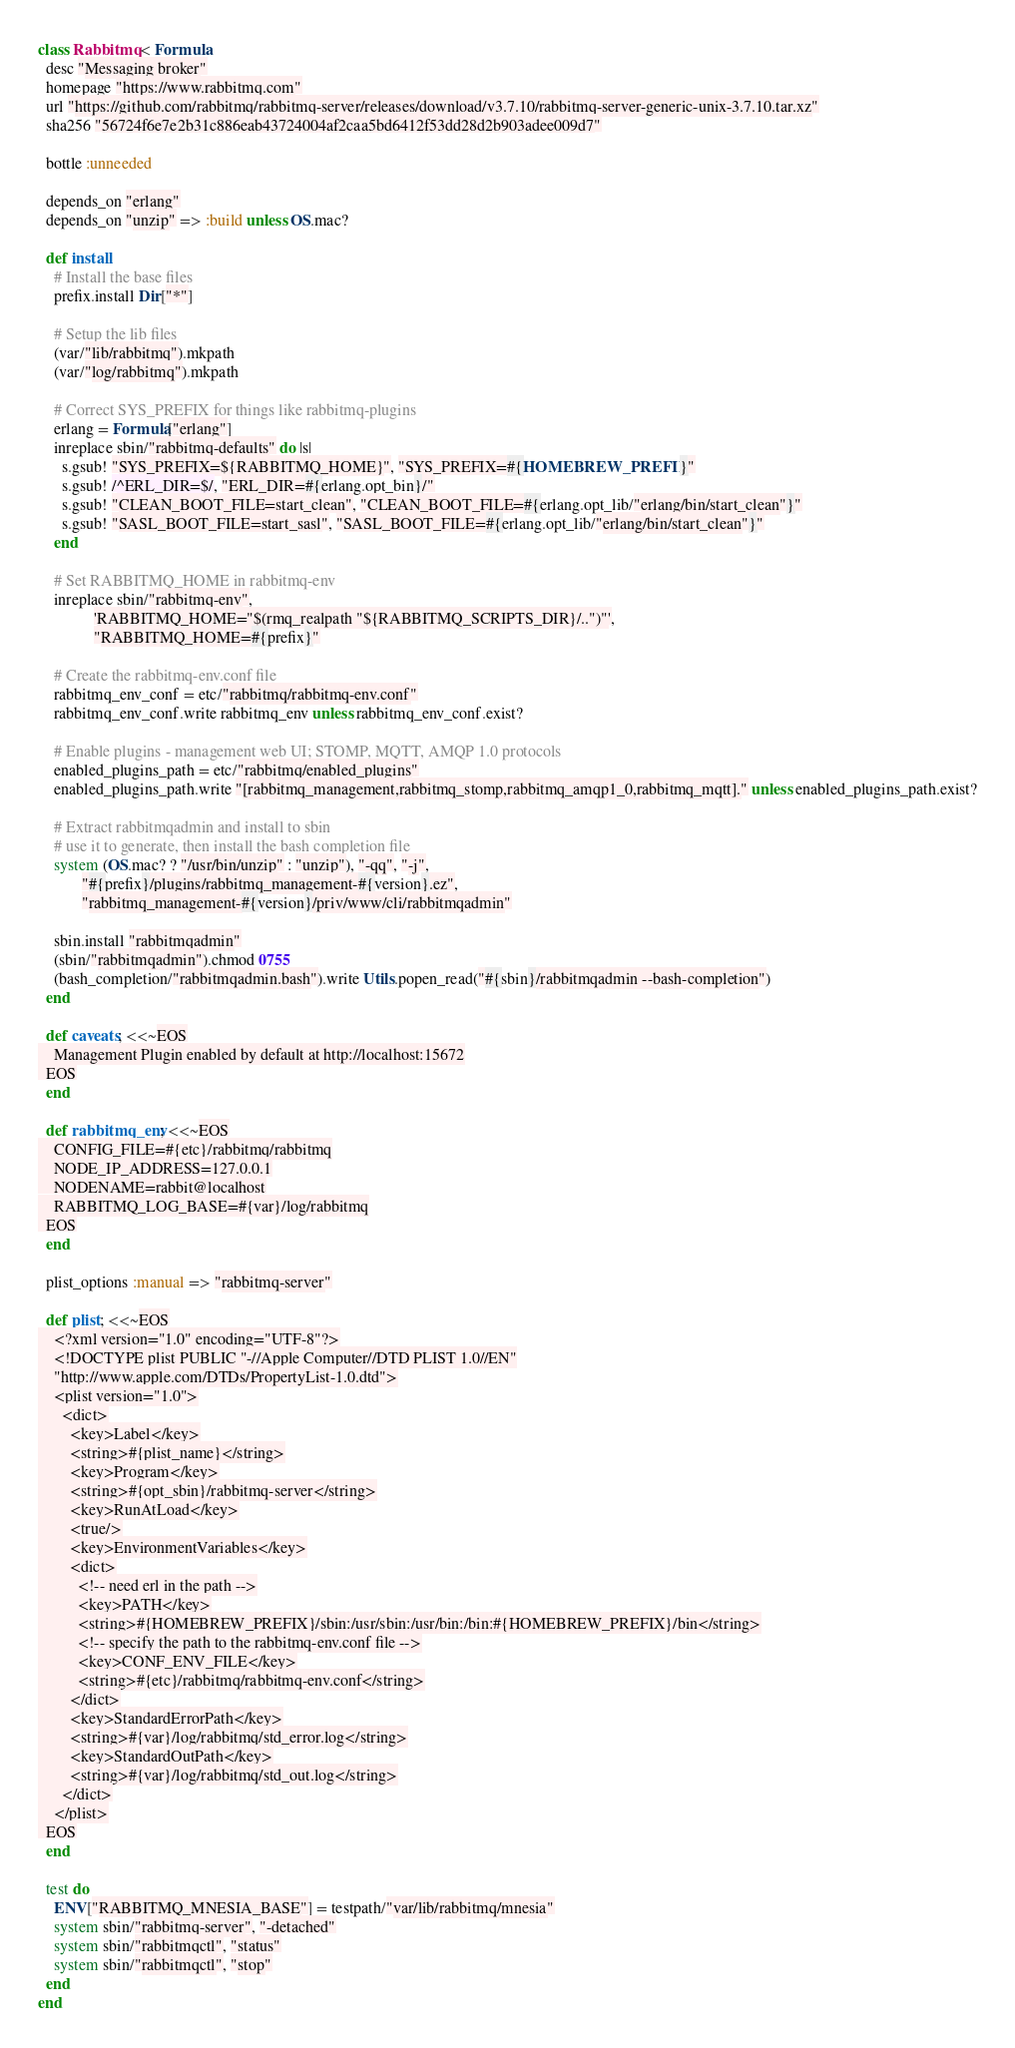Convert code to text. <code><loc_0><loc_0><loc_500><loc_500><_Ruby_>class Rabbitmq < Formula
  desc "Messaging broker"
  homepage "https://www.rabbitmq.com"
  url "https://github.com/rabbitmq/rabbitmq-server/releases/download/v3.7.10/rabbitmq-server-generic-unix-3.7.10.tar.xz"
  sha256 "56724f6e7e2b31c886eab43724004af2caa5bd6412f53dd28d2b903adee009d7"

  bottle :unneeded

  depends_on "erlang"
  depends_on "unzip" => :build unless OS.mac?

  def install
    # Install the base files
    prefix.install Dir["*"]

    # Setup the lib files
    (var/"lib/rabbitmq").mkpath
    (var/"log/rabbitmq").mkpath

    # Correct SYS_PREFIX for things like rabbitmq-plugins
    erlang = Formula["erlang"]
    inreplace sbin/"rabbitmq-defaults" do |s|
      s.gsub! "SYS_PREFIX=${RABBITMQ_HOME}", "SYS_PREFIX=#{HOMEBREW_PREFIX}"
      s.gsub! /^ERL_DIR=$/, "ERL_DIR=#{erlang.opt_bin}/"
      s.gsub! "CLEAN_BOOT_FILE=start_clean", "CLEAN_BOOT_FILE=#{erlang.opt_lib/"erlang/bin/start_clean"}"
      s.gsub! "SASL_BOOT_FILE=start_sasl", "SASL_BOOT_FILE=#{erlang.opt_lib/"erlang/bin/start_clean"}"
    end

    # Set RABBITMQ_HOME in rabbitmq-env
    inreplace sbin/"rabbitmq-env",
              'RABBITMQ_HOME="$(rmq_realpath "${RABBITMQ_SCRIPTS_DIR}/..")"',
              "RABBITMQ_HOME=#{prefix}"

    # Create the rabbitmq-env.conf file
    rabbitmq_env_conf = etc/"rabbitmq/rabbitmq-env.conf"
    rabbitmq_env_conf.write rabbitmq_env unless rabbitmq_env_conf.exist?

    # Enable plugins - management web UI; STOMP, MQTT, AMQP 1.0 protocols
    enabled_plugins_path = etc/"rabbitmq/enabled_plugins"
    enabled_plugins_path.write "[rabbitmq_management,rabbitmq_stomp,rabbitmq_amqp1_0,rabbitmq_mqtt]." unless enabled_plugins_path.exist?

    # Extract rabbitmqadmin and install to sbin
    # use it to generate, then install the bash completion file
    system (OS.mac? ? "/usr/bin/unzip" : "unzip"), "-qq", "-j",
           "#{prefix}/plugins/rabbitmq_management-#{version}.ez",
           "rabbitmq_management-#{version}/priv/www/cli/rabbitmqadmin"

    sbin.install "rabbitmqadmin"
    (sbin/"rabbitmqadmin").chmod 0755
    (bash_completion/"rabbitmqadmin.bash").write Utils.popen_read("#{sbin}/rabbitmqadmin --bash-completion")
  end

  def caveats; <<~EOS
    Management Plugin enabled by default at http://localhost:15672
  EOS
  end

  def rabbitmq_env; <<~EOS
    CONFIG_FILE=#{etc}/rabbitmq/rabbitmq
    NODE_IP_ADDRESS=127.0.0.1
    NODENAME=rabbit@localhost
    RABBITMQ_LOG_BASE=#{var}/log/rabbitmq
  EOS
  end

  plist_options :manual => "rabbitmq-server"

  def plist; <<~EOS
    <?xml version="1.0" encoding="UTF-8"?>
    <!DOCTYPE plist PUBLIC "-//Apple Computer//DTD PLIST 1.0//EN"
    "http://www.apple.com/DTDs/PropertyList-1.0.dtd">
    <plist version="1.0">
      <dict>
        <key>Label</key>
        <string>#{plist_name}</string>
        <key>Program</key>
        <string>#{opt_sbin}/rabbitmq-server</string>
        <key>RunAtLoad</key>
        <true/>
        <key>EnvironmentVariables</key>
        <dict>
          <!-- need erl in the path -->
          <key>PATH</key>
          <string>#{HOMEBREW_PREFIX}/sbin:/usr/sbin:/usr/bin:/bin:#{HOMEBREW_PREFIX}/bin</string>
          <!-- specify the path to the rabbitmq-env.conf file -->
          <key>CONF_ENV_FILE</key>
          <string>#{etc}/rabbitmq/rabbitmq-env.conf</string>
        </dict>
        <key>StandardErrorPath</key>
        <string>#{var}/log/rabbitmq/std_error.log</string>
        <key>StandardOutPath</key>
        <string>#{var}/log/rabbitmq/std_out.log</string>
      </dict>
    </plist>
  EOS
  end

  test do
    ENV["RABBITMQ_MNESIA_BASE"] = testpath/"var/lib/rabbitmq/mnesia"
    system sbin/"rabbitmq-server", "-detached"
    system sbin/"rabbitmqctl", "status"
    system sbin/"rabbitmqctl", "stop"
  end
end
</code> 